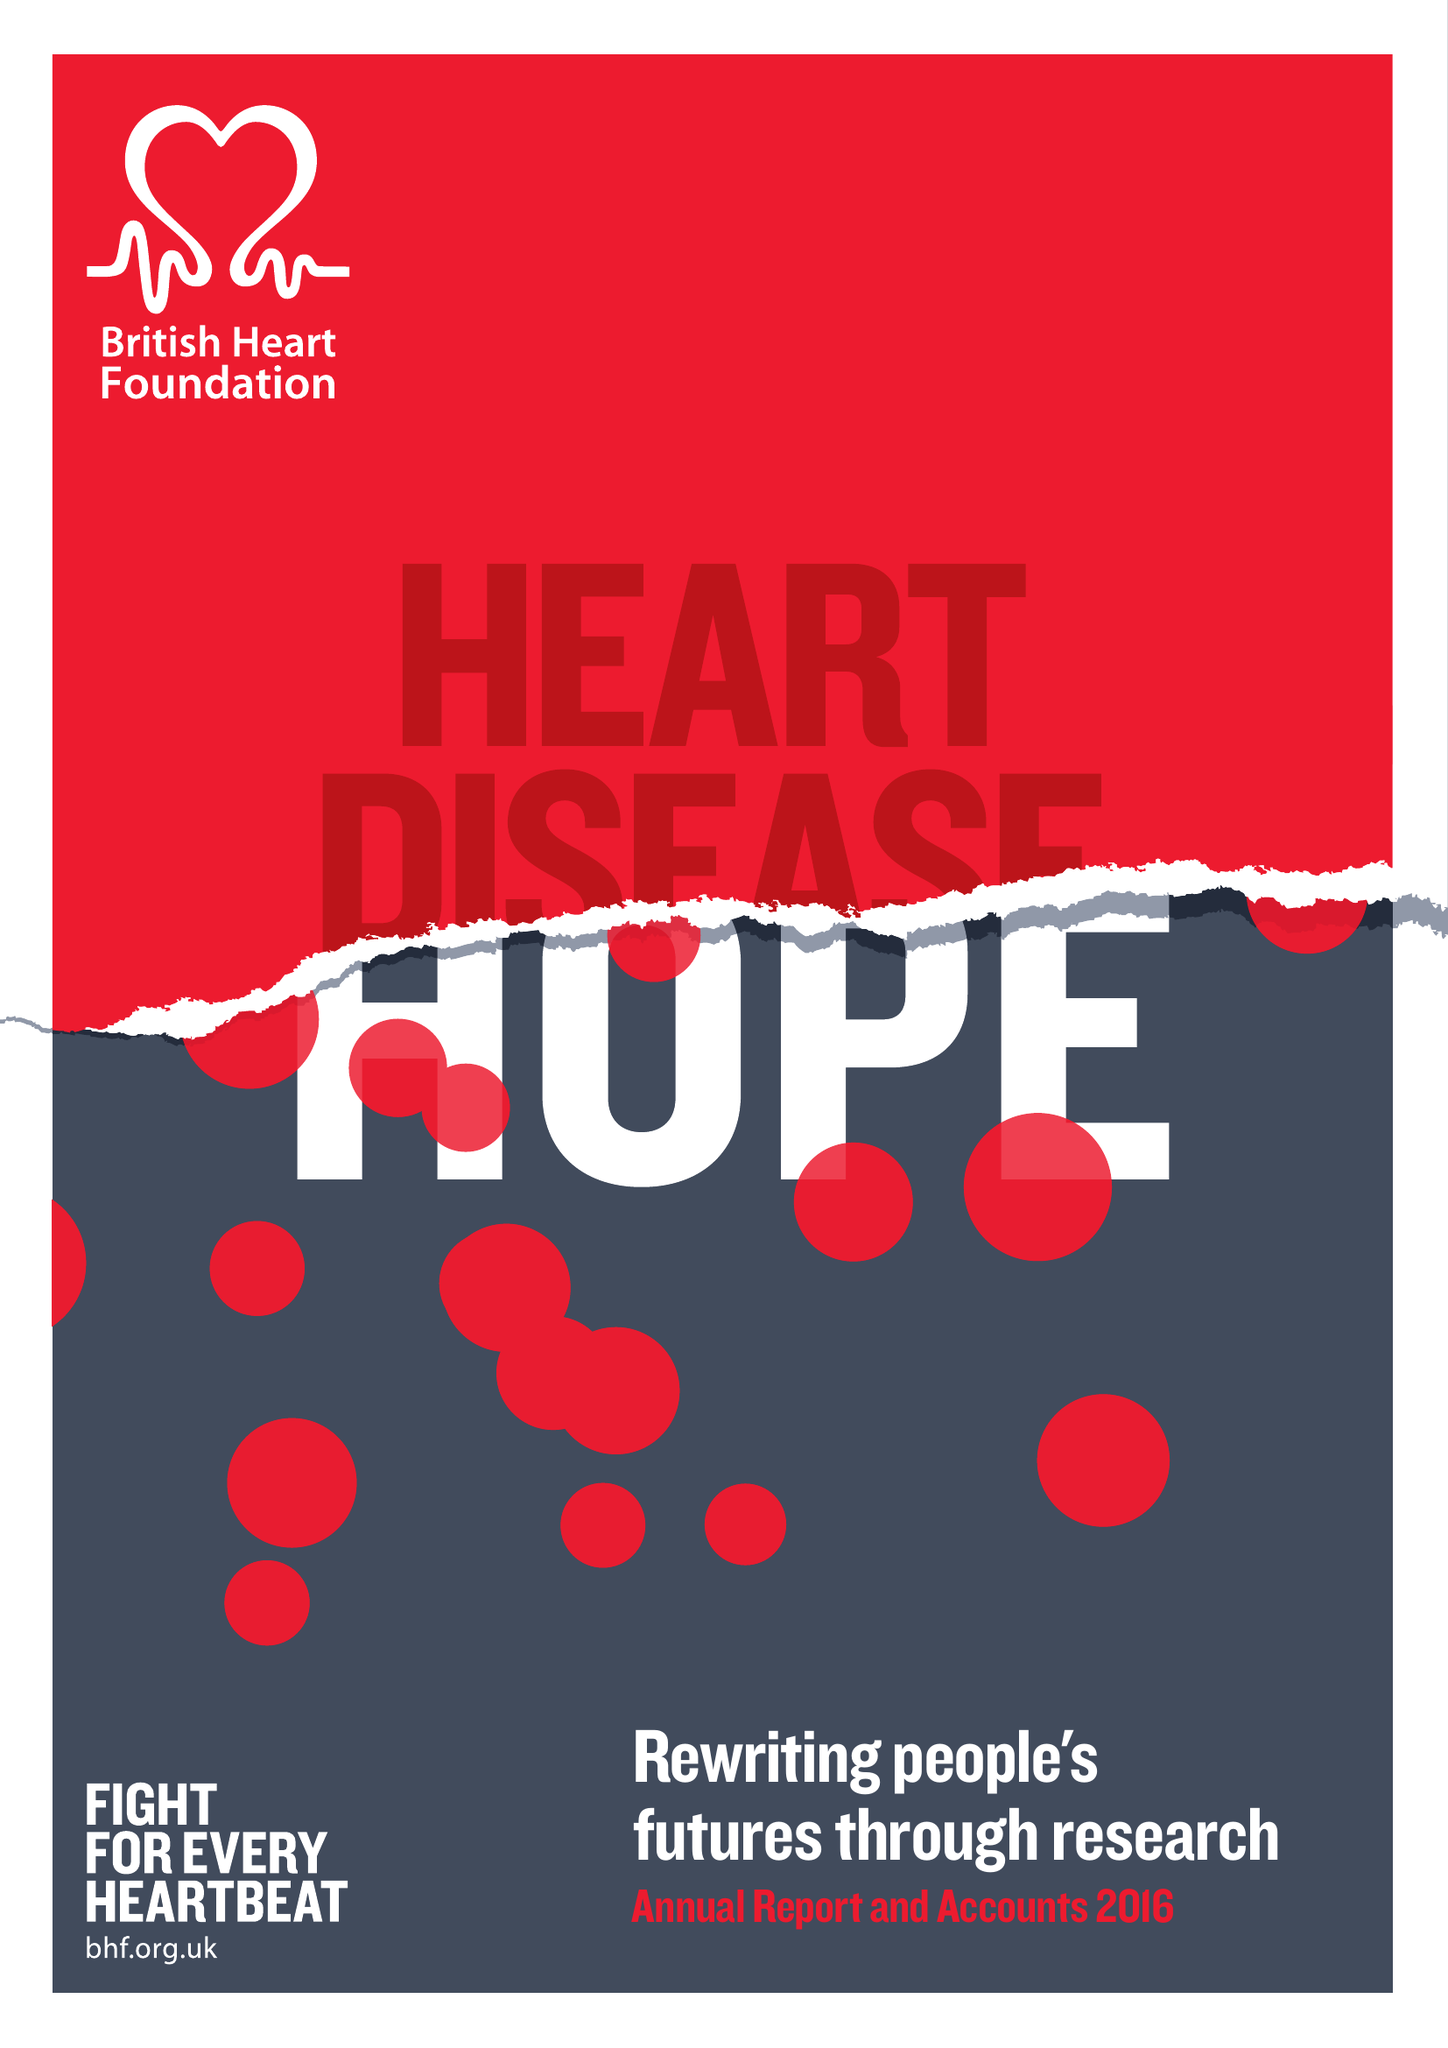What is the value for the charity_number?
Answer the question using a single word or phrase. 225971 